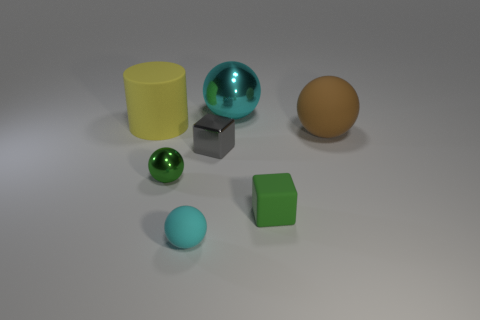The other tiny thing that is the same shape as the green matte object is what color? gray 